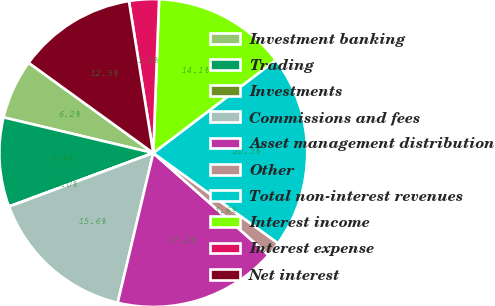<chart> <loc_0><loc_0><loc_500><loc_500><pie_chart><fcel>Investment banking<fcel>Trading<fcel>Investments<fcel>Commissions and fees<fcel>Asset management distribution<fcel>Other<fcel>Total non-interest revenues<fcel>Interest income<fcel>Interest expense<fcel>Net interest<nl><fcel>6.25%<fcel>9.38%<fcel>0.01%<fcel>15.62%<fcel>17.18%<fcel>1.57%<fcel>20.3%<fcel>14.06%<fcel>3.13%<fcel>12.5%<nl></chart> 